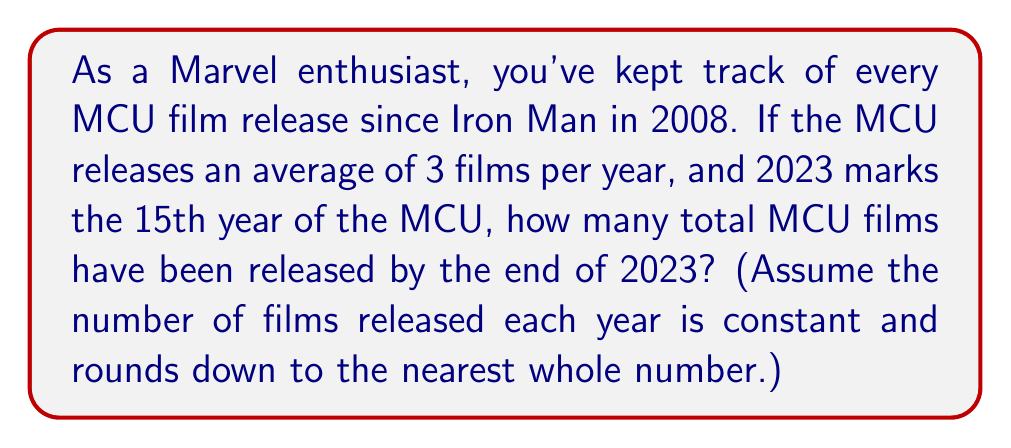Help me with this question. Let's approach this step-by-step:

1. First, we need to calculate the number of years the MCU has been releasing films:
   $$\text{Years} = 2023 - 2008 + 1 = 16$$
   We add 1 because we're including both 2008 and 2023.

2. Now, we know that on average, 3 films are released per year. We can express this as:
   $$\text{Films per year} = 3$$

3. To find the total number of films, we multiply the number of years by the number of films per year:
   $$\text{Total films} = \text{Years} \times \text{Films per year}$$
   $$\text{Total films} = 16 \times 3 = 48$$

4. However, the question states that we should round down to the nearest whole number each year. This means that over 15 years, we've actually missed out on 15 fractional films:
   $$\text{Missed films} = 15 \times 0.0 = 0$$
   (Since 3 is already a whole number, we don't actually miss any films in this case)

5. Therefore, our final calculation is:
   $$\text{Total MCU films} = 48 - 0 = 48$$
Answer: 48 MCU films have been released by the end of 2023. 